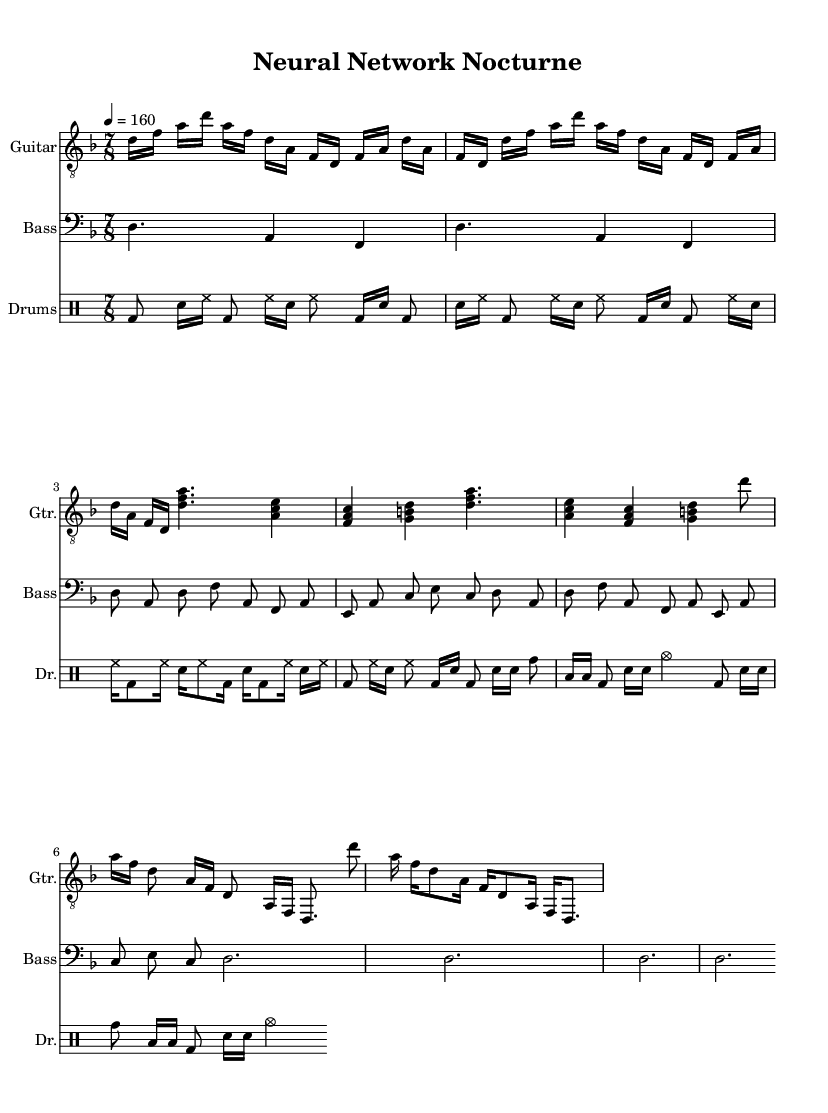What is the key signature of this music? The key signature is D minor, which has one flat (B flat). This can be determined from the key signature shown at the beginning of the score.
Answer: D minor What is the time signature of the music? The time signature is 7/8, indicated by the numbers shown in the time signature section of the sheet music at the beginning of the score.
Answer: 7/8 What is the tempo marking for the piece? The tempo marking indicates that the piece should be played at a speed of 160 beats per minute, as noted at the beginning of the score.
Answer: 160 How many repetitions are there in the guitar intro? The guitar intro is repeated twice, as indicated by the directive to repeat the section. This can be found in the measures labeled for the guitar intro.
Answer: 2 Identify the instrument playing the first part of the intro. The first part of the intro is played by the guitar, as specified in the instrument names at the beginning of each staff.
Answer: Guitar What rhythmic pattern is prevalent in the drum part? The prevalent rhythmic pattern in the drum part consists of a kick drum followed by snare and hi-hat, which is repeated and provides a driving rhythmic foundation. Combining this rhythmic motif with its repetitions provides the energy characteristic of the metal genre.
Answer: Kick and snare Describe the dynamics indicated in the chorus section. The chorus section maintains a forte dynamic, which illustrates a strong, powerful sound typical in metal music. This dynamic is understood through performance context rather than explicit notation; however, the musical elements suggest an intense feeling.
Answer: Forte 